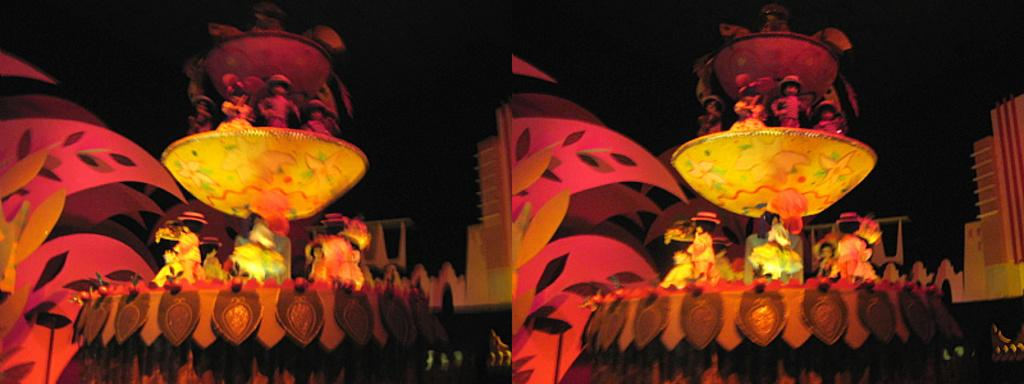What can be observed about the nature of the image? The image is edited. How many pictures are present in the image? There are two pictures in the image. What objects are located in the middle of the image? There are toys in the middle of the image. What type of vegetable is being argued over in the image? There is no argument or vegetable present in the image; it features two pictures and toys in the middle. 